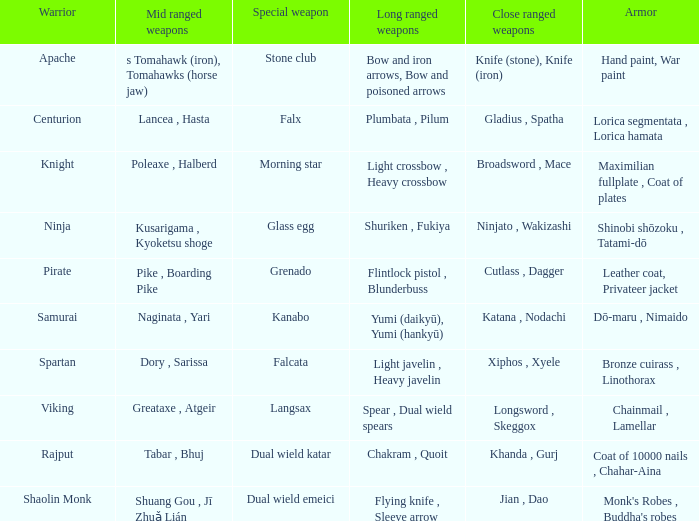If the special weapon is glass egg, what is the close ranged weapon? Ninjato , Wakizashi. 